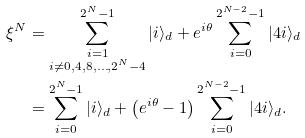<formula> <loc_0><loc_0><loc_500><loc_500>\xi ^ { N } & = \sum _ { \substack { i = 1 \\ i \not = 0 , 4 , 8 , \dots , 2 ^ { N } - 4 } } ^ { 2 ^ { N } - 1 } | i \rangle _ { d } + e ^ { i \theta } \sum _ { i = 0 } ^ { 2 ^ { N - 2 } - 1 } | 4 i \rangle _ { d } \\ & = \sum _ { i = 0 } ^ { 2 ^ { N } - 1 } | i \rangle _ { d } + \left ( e ^ { i \theta } - 1 \right ) \sum _ { i = 0 } ^ { 2 ^ { N - 2 } - 1 } | 4 i \rangle _ { d } .</formula> 